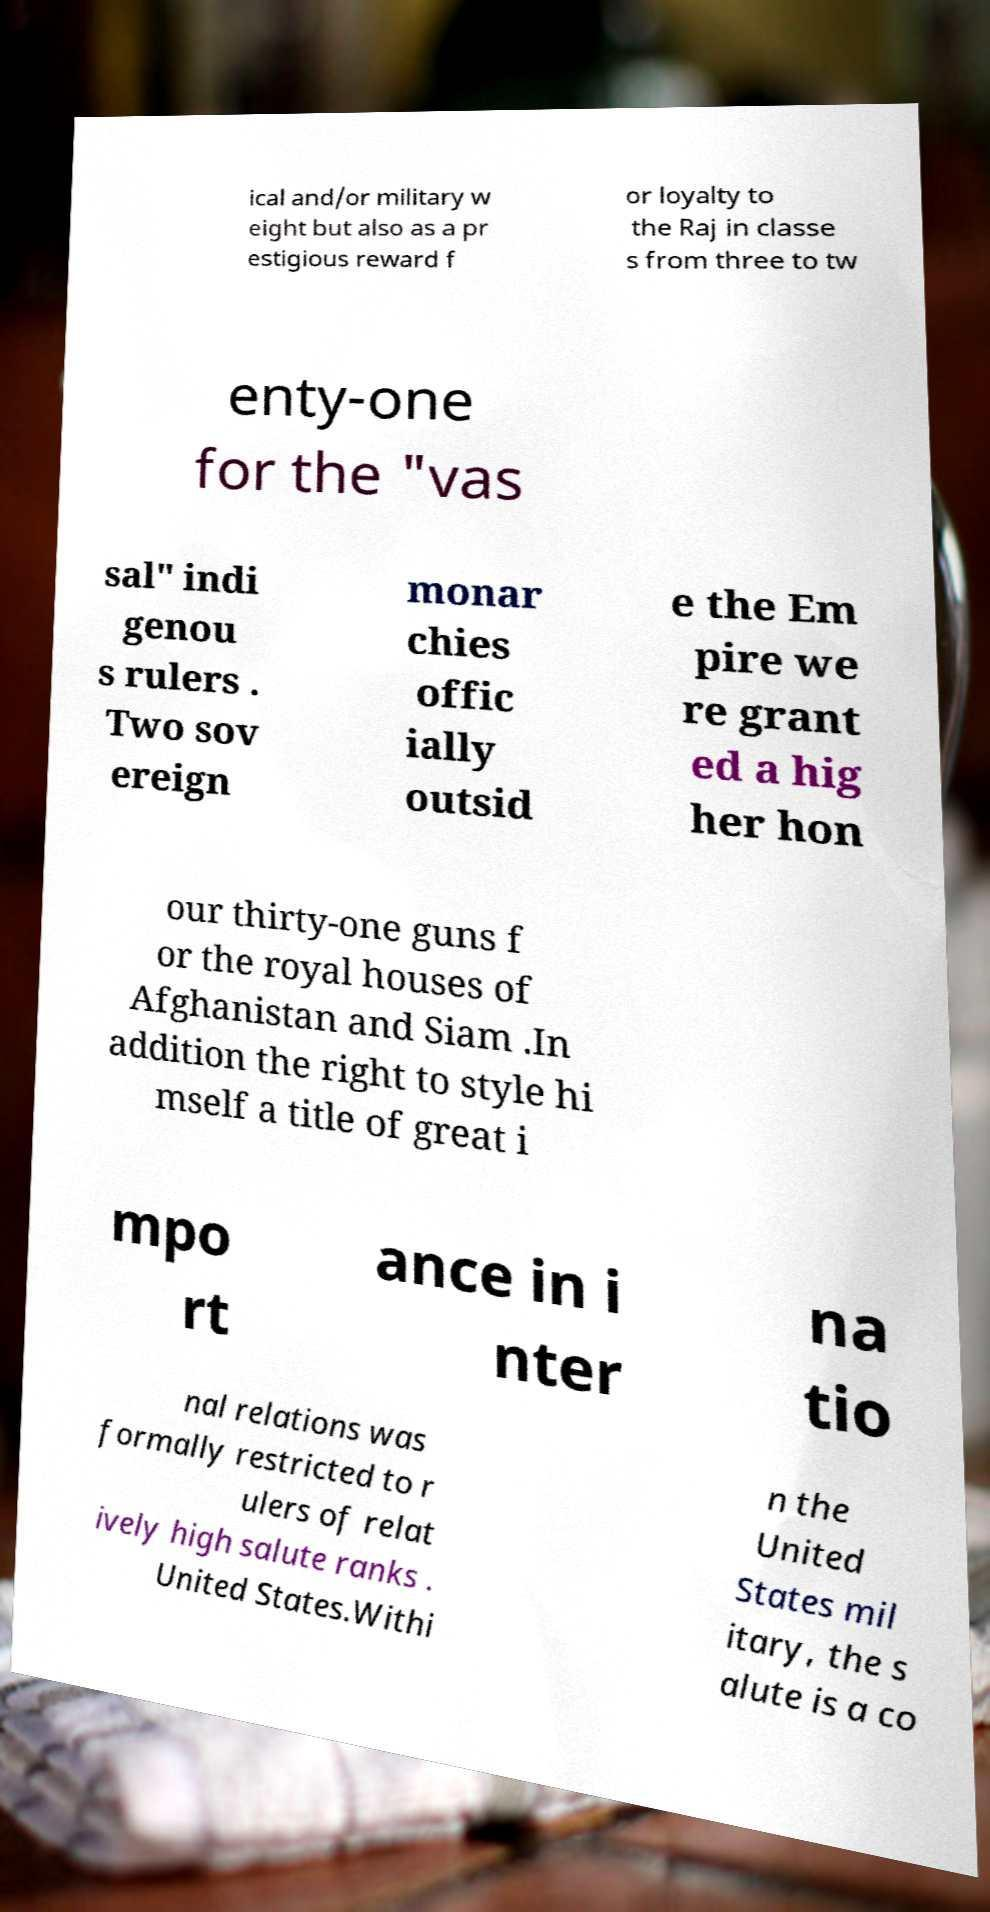Please read and relay the text visible in this image. What does it say? ical and/or military w eight but also as a pr estigious reward f or loyalty to the Raj in classe s from three to tw enty-one for the "vas sal" indi genou s rulers . Two sov ereign monar chies offic ially outsid e the Em pire we re grant ed a hig her hon our thirty-one guns f or the royal houses of Afghanistan and Siam .In addition the right to style hi mself a title of great i mpo rt ance in i nter na tio nal relations was formally restricted to r ulers of relat ively high salute ranks . United States.Withi n the United States mil itary, the s alute is a co 